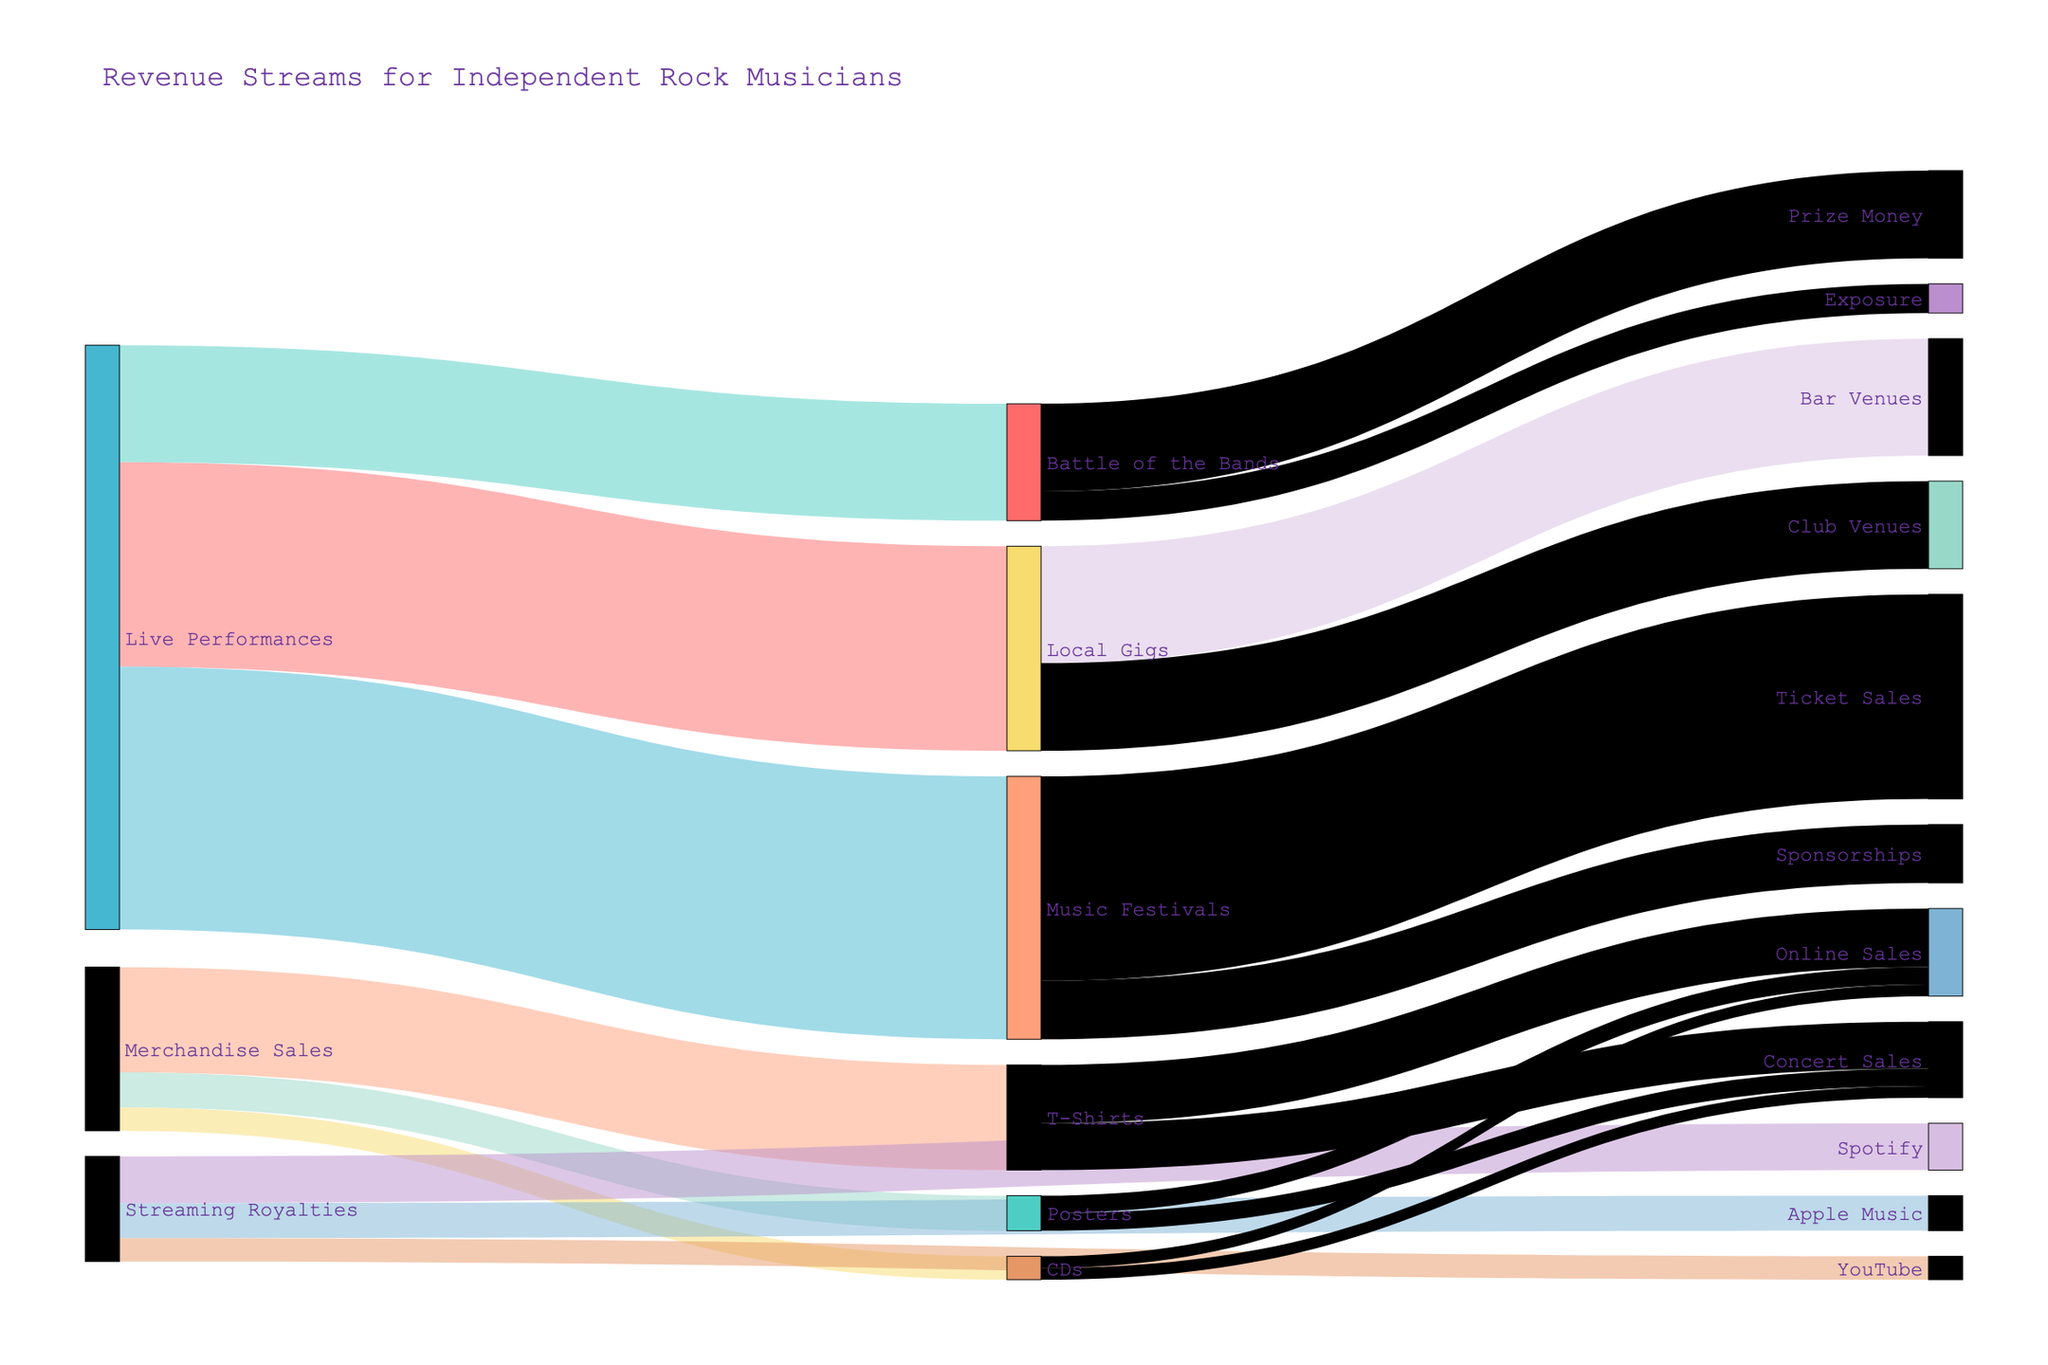What's the primary revenue stream for independent rock musicians in the figure? To determine the primary revenue stream, look at the sources with the highest values. "Live Performances" has the highest combined value of 10,000 compared to "Merchandise Sales" and "Streaming Royalties".
Answer: Live Performances What's the total revenue generated from merchandise sales? Add up the values associated with "Merchandise Sales": 1800 (T-Shirts) + 600 (Posters) + 400 (CDs) = 2800.
Answer: 2800 Which streaming platform generates the highest royalties for the musicians? Compare the values of streaming royalties: Spotify (800), Apple Music (600), YouTube (400). Spotify has the highest value.
Answer: Spotify How much more revenue comes from music festivals compared to local gigs? First, calculate the total for music festivals: 4500. For local gigs: 3500. The difference is 4500 - 3500 = 1000.
Answer: 1000 What's the combined revenue from all streaming platforms? Add the values from Spotify (800), Apple Music (600), and YouTube (400): 800 + 600 + 400 = 1800.
Answer: 1800 Of the merchandise categories, which generates the least revenue? Compare the values: T-Shirts (1800), Posters (600), CDs (400). CDs generate the least revenue.
Answer: CDs Between ticket sales and sponsorships at music festivals, which brings in more money? Compare their values: Ticket Sales (3500) and Sponsorships (1000). Ticket Sales bring in more money.
Answer: Ticket Sales What's the total revenue generated from "Concert Sales" within merchandise sales? Add up the values associated with "Concert Sales": T-Shirts (800) + Posters (300) + CDs (200) = 1300.
Answer: 1300 By how much does the revenue from battle of the bands exceed the revenue from YouTube streaming? Compare the values: Battle of the Bands (2000) and YouTube (400). The difference is 2000 - 400 = 1600.
Answer: 1600 